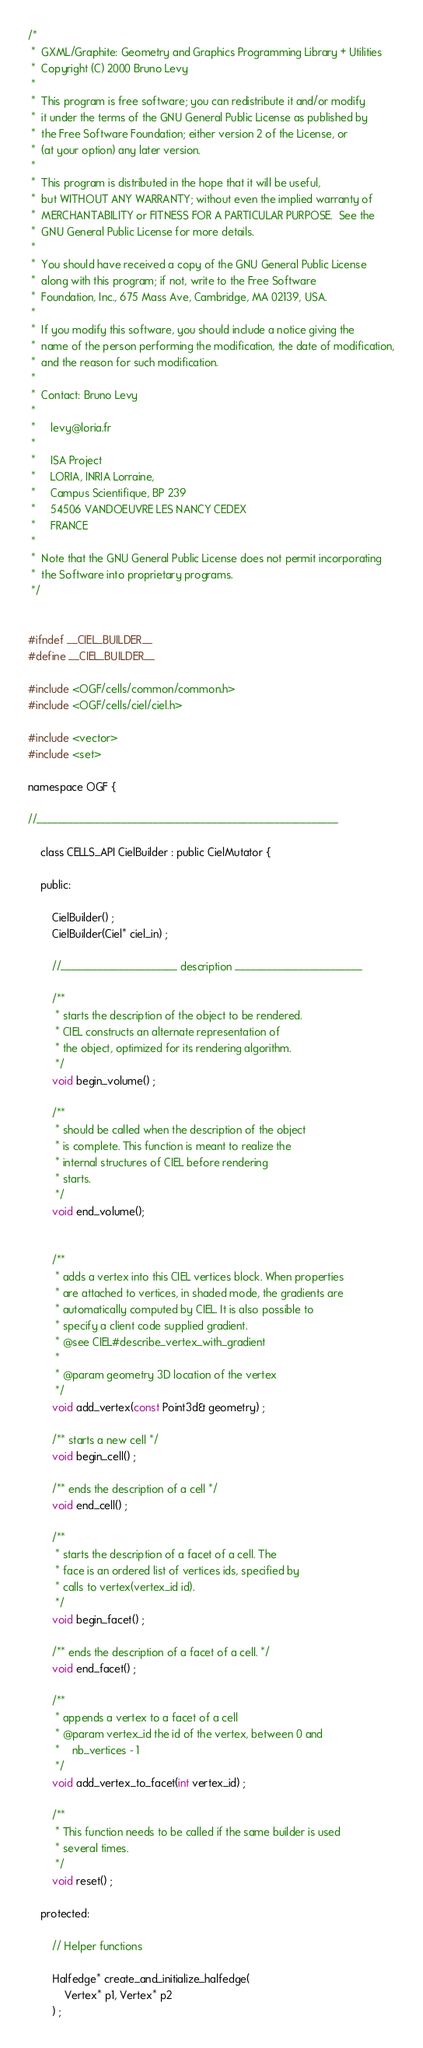<code> <loc_0><loc_0><loc_500><loc_500><_C_>/*
 *  GXML/Graphite: Geometry and Graphics Programming Library + Utilities
 *  Copyright (C) 2000 Bruno Levy
 *
 *  This program is free software; you can redistribute it and/or modify
 *  it under the terms of the GNU General Public License as published by
 *  the Free Software Foundation; either version 2 of the License, or
 *  (at your option) any later version.
 *
 *  This program is distributed in the hope that it will be useful,
 *  but WITHOUT ANY WARRANTY; without even the implied warranty of
 *  MERCHANTABILITY or FITNESS FOR A PARTICULAR PURPOSE.  See the
 *  GNU General Public License for more details.
 *
 *  You should have received a copy of the GNU General Public License
 *  along with this program; if not, write to the Free Software
 *  Foundation, Inc., 675 Mass Ave, Cambridge, MA 02139, USA.
 *
 *  If you modify this software, you should include a notice giving the
 *  name of the person performing the modification, the date of modification,
 *  and the reason for such modification.
 *
 *  Contact: Bruno Levy
 *
 *     levy@loria.fr
 *
 *     ISA Project
 *     LORIA, INRIA Lorraine, 
 *     Campus Scientifique, BP 239
 *     54506 VANDOEUVRE LES NANCY CEDEX 
 *     FRANCE
 *
 *  Note that the GNU General Public License does not permit incorporating
 *  the Software into proprietary programs. 
 */
 

#ifndef __CIEL_BUILDER__
#define __CIEL_BUILDER__

#include <OGF/cells/common/common.h>
#include <OGF/cells/ciel/ciel.h>

#include <vector>
#include <set>

namespace OGF {

//_________________________________________________________

    class CELLS_API CielBuilder : public CielMutator {
        
    public:

        CielBuilder() ;
        CielBuilder(Ciel* ciel_in) ;

        //______________________ description ________________________
        
        /**
         * starts the description of the object to be rendered. 
         * CIEL constructs an alternate representation of
         * the object, optimized for its rendering algorithm.
         */
        void begin_volume() ;

        /**
         * should be called when the description of the object
         * is complete. This function is meant to realize the
         * internal structures of CIEL before rendering
         * starts.
         */
        void end_volume();


        /**
         * adds a vertex into this CIEL vertices block. When properties
         * are attached to vertices, in shaded mode, the gradients are
         * automatically computed by CIEL. It is also possible to
         * specify a client code supplied gradient.
         * @see CIEL#describe_vertex_with_gradient
         *
         * @param geometry 3D location of the vertex
         */
        void add_vertex(const Point3d& geometry) ;

        /** starts a new cell */
        void begin_cell() ;

        /** ends the description of a cell */
        void end_cell() ;

        /**
         * starts the description of a facet of a cell. The
         * face is an ordered list of vertices ids, specified by
         * calls to vertex(vertex_id id).
         */
        void begin_facet() ;
        
        /** ends the description of a facet of a cell. */
        void end_facet() ;

        /**
         * appends a vertex to a facet of a cell
         * @param vertex_id the id of the vertex, between 0 and
         *    nb_vertices - 1
         */
        void add_vertex_to_facet(int vertex_id) ;

        /**
         * This function needs to be called if the same builder is used
         * several times.
         */
        void reset() ;

    protected:

        // Helper functions

        Halfedge* create_and_initialize_halfedge(
            Vertex* p1, Vertex* p2
        ) ;        
</code> 